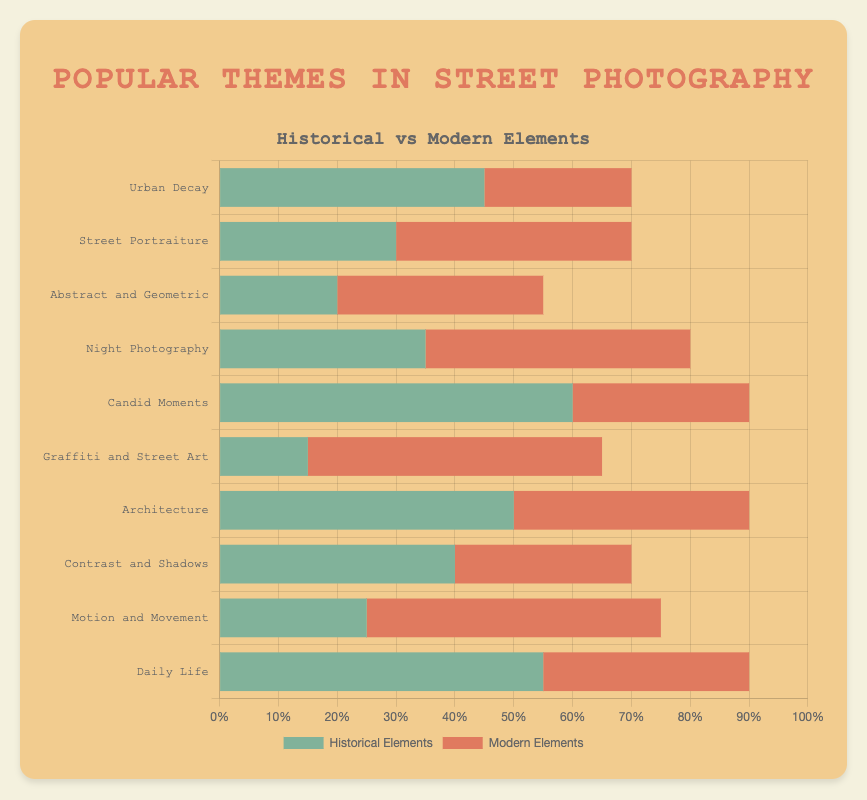Which theme has the highest number of historical elements? The 'Candid Moments' theme has the highest number of historical elements with a value of 60. This is evident from the longest green bar in the 'Historical Elements' dataset.
Answer: Candid Moments Which theme has more modern elements than historical elements? Several themes qualify, but 'Graffiti and Street Art' has one of the most noticeable differences, with 50 modern elements compared to 15 historical elements.
Answer: Graffiti and Street Art What is the total percentage of elements (historical and modern) in the 'Night Photography' theme? Add the historical (35) and modern (45) elements for 'Night Photography': 35 + 45 = 80. The combined percentage is 80%.
Answer: 80% Which theme has the smallest percentage of historical elements? The 'Graffiti and Street Art' theme has the smallest percentage of historical elements at 15%. This can be observed by the shortest green bar in the horizontal stacked bar chart.
Answer: Graffiti and Street Art Compare 'Urban Decay' and 'Motion and Movement' in terms of total elements. Which theme has a higher total? For 'Urban Decay', the total is 45 (historical) + 25 (modern) = 70. For 'Motion and Movement', it's 25 (historical) + 50 (modern) = 75. Thus, 'Motion and Movement' has a higher total.
Answer: Motion and Movement Which theme has an equal share of historical and modern elements? No theme has an equal share, but 'Architecture' comes close with 50 historical and 40 modern elements.
Answer: None What is the average number of modern elements across all themes? Sum the modern elements: 25 + 40 + 35 + 45 + 30 + 50 + 40 + 30 + 50 + 35 = 380. There are 10 themes, so the average is 380 / 10 = 38.
Answer: 38 In 'Contrast and Shadows', is the difference between historical and modern elements large or small? The difference is 40 (historical) - 30 (modern) = 10. This is a small difference compared to other themes.
Answer: Small Which theme overall has the highest combined share of elements? Calculate the total number of elements for each theme and identify the highest. 'Candid Moments' has the highest total with 60 (historical) + 30 (modern) = 90.
Answer: Candid Moments 